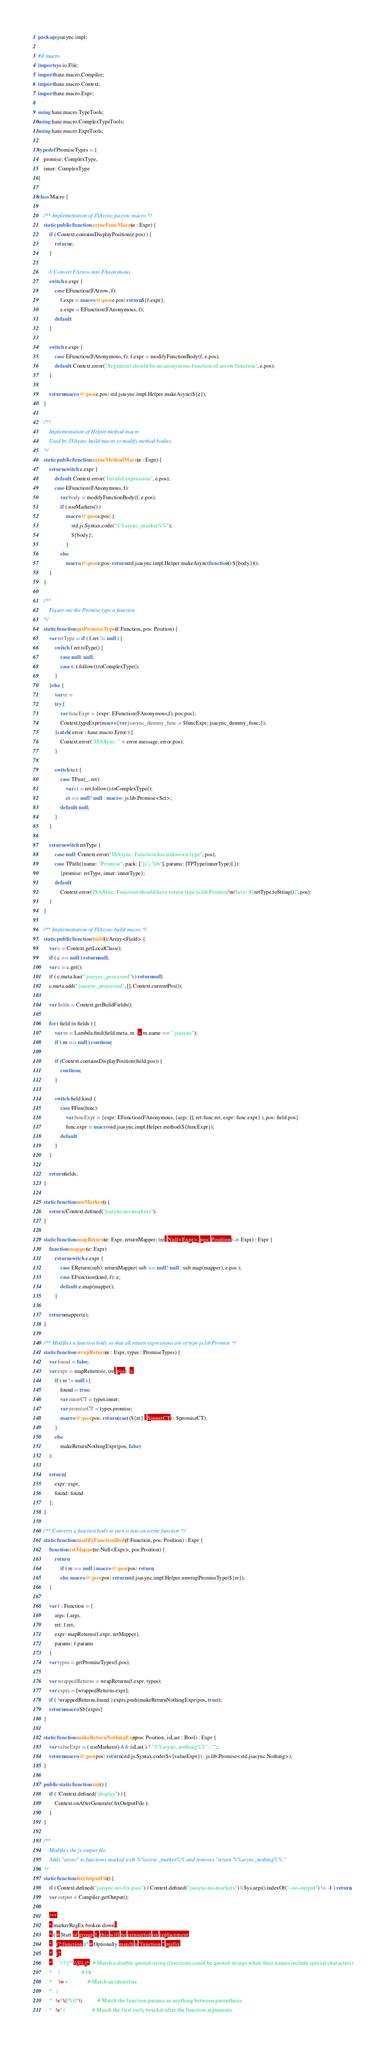<code> <loc_0><loc_0><loc_500><loc_500><_Haxe_>package jsasync.impl;

#if macro
import sys.io.File;
import haxe.macro.Compiler;
import haxe.macro.Context;
import haxe.macro.Expr;

using haxe.macro.TypeTools;
using haxe.macro.ComplexTypeTools;
using haxe.macro.ExprTools;

typedef PromiseTypes = {
	promise: ComplexType,
	inner: ComplexType
}

class Macro {

	/** Implementation of JSAsync.jsasync macro */
	static public function asyncFuncMacro(e : Expr) {
		if ( Context.containsDisplayPosition(e.pos) ) {
			return e;
		}

		// Convert FArrow into FAnonymous
		switch e.expr {
			case EFunction(FArrow, f):
				f.expr = macro @:pos(e.pos) return ${f.expr};
				e.expr = EFunction(FAnonymous, f);
			default:
		}

		switch e.expr {
			case EFunction(FAnonymous, f): f.expr = modifyFunctionBody(f, e.pos);
			default: Context.error("Argument should be an anonymous function of arrow function", e.pos);
		}

		return macro @:pos(e.pos) std.jsasync.impl.Helper.makeAsync(${e});
	}

	/**
		Implementation of Helper.method macro
		Used by JSAsync build macro to modify method bodies.
	*/
	static public function asyncMethodMacro(e : Expr) {
		return switch e.expr {
			default: Context.error("Invalid expression", e.pos);
			case EFunction(FAnonymous, f):
				var body = modifyFunctionBody(f, e.pos);
				if ( useMarkers() )
					macro @:pos(e.pos) {
						std.js.Syntax.code("%%async_marker%%");
						${body};
					}
				else
					macro @:pos(e.pos) return std.jsasync.impl.Helper.makeAsync(function() ${body})();
		}
	}

	/**
		Figure out the Promise type a function
	*/
	static function getPromiseTypes(f:Function, pos: Position) {
		var retType = if ( f.ret != null ) {
			switch f.ret.toType() {
				case null: null;
				case t: t.follow().toComplexType();
			}
		}else {
			var te =
			try {
				var funcExpr = {expr: EFunction(FAnonymous,f), pos:pos};
				Context.typeExpr(macro {var jsasync_dummy_func = $funcExpr; jsasync_dummy_func;});
			}catch( error : haxe.macro.Error ) {
				Context.error("JSASync: " + error.message, error.pos);
			}

			switch te.t {
				case TFun(_, ret):
					var ct = ret.follow().toComplexType();
					ct == null? null : macro : js.lib.Promise<$ct>;
				default: null;
			}
		}

		return switch retType {
			case null: Context.error("JSAsync: Function has unknown type", pos);
			case TPath({name: "Promise", pack: ["js", "lib"], params: [TPType(innerType)] }):
				{promise: retType, inner: innerType};
			default:
				Context.error('JSASync: Function should have return type js.lib.Promise\nHave: ${retType.toString()}', pos);
		}
	}

	/** Implementation of JSAsync.build macro */
	static public function build():Array<Field> {
		var c = Context.getLocalClass();
		if ( c == null ) return null;
		var c = c.get();
		if ( c.meta.has(":jsasync_processed") ) return null;
		c.meta.add(":jsasync_processed", [], Context.currentPos());

		var fields = Context.getBuildFields();

		for ( field in fields ) {
			var m = Lambda.find(field.meta, m -> m.name == ":jsasync");
			if ( m == null ) continue;

			if (Context.containsDisplayPosition(field.pos)) {
				continue;
			}

			switch field.kind {
				case FFun(func):
					var funcExpr = {expr: EFunction(FAnonymous, {args: [], ret:func.ret, expr: func.expr} ), pos: field.pos}
					func.expr = macro std.jsasync.impl.Helper.method(${funcExpr});
				default:
			}
		}

		return fields;
	}

	static function useMarkers() {
		return !Context.defined("jsasync-no-markers");
	}

	static function mapReturns(e: Expr, returnMapper: (re: Null<Expr>, pos: Position) -> Expr) : Expr {
		function mapper(e: Expr)
			return switch e.expr {
				case EReturn(sub): returnMapper( sub == null? null : sub.map(mapper), e.pos );
				case EFunction(kind, f): e;
				default: e.map(mapper);
			}

		return mapper(e);
	}

	/** Modifies a function body so that all return expressions are of type js.lib.Promise */
	static function wrapReturns(e : Expr, types : PromiseTypes) {
		var found = false;
		var expr = mapReturns(e, (re, pos) ->
			if ( re != null ) {
				found = true;
				var innerCT = types.inner;
				var promiseCT = types.promise;
				macro @:pos(pos) return (cast (${re} : $innerCT) : $promiseCT);
			}
			else
				makeReturnNothingExpr(pos, false)
		);

		return {
			expr: expr,
			found: found
		};
	}

	/** Converts a function body to turn it into an async function */
	static function modifyFunctionBody(f:Function, pos: Position) : Expr {
		function retMapper(re:Null<Expr>, pos:Position) {
			return
				if ( re == null ) macro @:pos(pos) return;
				else macro @:pos(pos) return std.jsasync.impl.Helper.unwrapPromiseType(${re});
		}

		var f : Function = {
			args: f.args,
			ret: f.ret,
			expr: mapReturns(f.expr, retMapper),
			params: f.params
		}
		var types = getPromiseTypes(f,pos);

		var wrappedReturns = wrapReturns(f.expr, types);
		var exprs = [wrappedReturns.expr];
		if ( !wrappedReturns.found ) exprs.push(makeReturnNothingExpr(pos, true));
		return macro $b{exprs}
	}
	
	static function makeReturnNothingExpr(pos: Position, isLast : Bool) : Expr {
		var valueExpr = ( useMarkers() && isLast ) ? "%%async_nothing%%" : "";
		return macro @:pos(pos) return (std.js.Syntax.code($v{valueExpr}) : js.lib.Promise<std.jsasync.Nothing>);
	}

	public static function init() {
		if ( !Context.defined("display") ) {
			Context.onAfterGenerate( fixOutputFile );
		}
	}

	/** 
		Modifies the js output file.
		Adds "async" to functions marked with %%async_marker%% and removes "return %%async_nothing%%;"
	*/
	static function fixOutputFile() {
		if ( Context.defined("jsasync-no-fix-pass") || Context.defined("jsasync-no-markers") || Sys.args().indexOf("--no-output") != -1 ) return;
		var output = Compiler.getOutput();
		
		/**
		* markerRegEx broken down:
		* ( # Start of group 1, this will be reinserted on replacement
		*   (?:function )? # Optionally match a "function " prefix
		*   (?:
		*     "(?:[^"\\]|\\.)*" # Match a double quoted string (functions could be quoted strings when their names include special characters)
		*     |                 # Or
		*     \w+               # Match an identifier
		*   )
		*   \s*\([^()]*\)            # Match the function params as anything between parenthesis.
		*   \s*{                     # Match the first curly bracket after the function arguments.</code> 